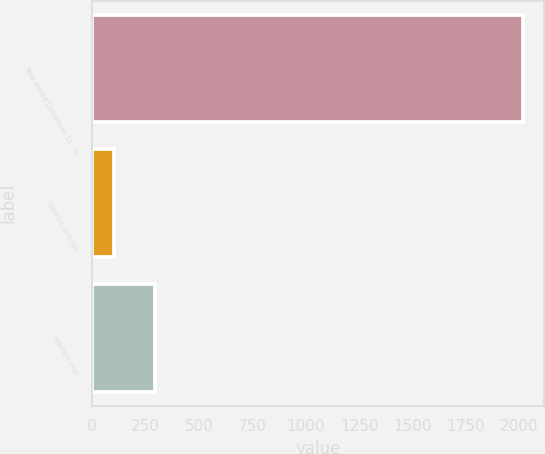Convert chart to OTSL. <chart><loc_0><loc_0><loc_500><loc_500><bar_chart><fcel>Year ended December 31 - in<fcel>Service cost (b)<fcel>Interest cost<nl><fcel>2016<fcel>102<fcel>293.4<nl></chart> 